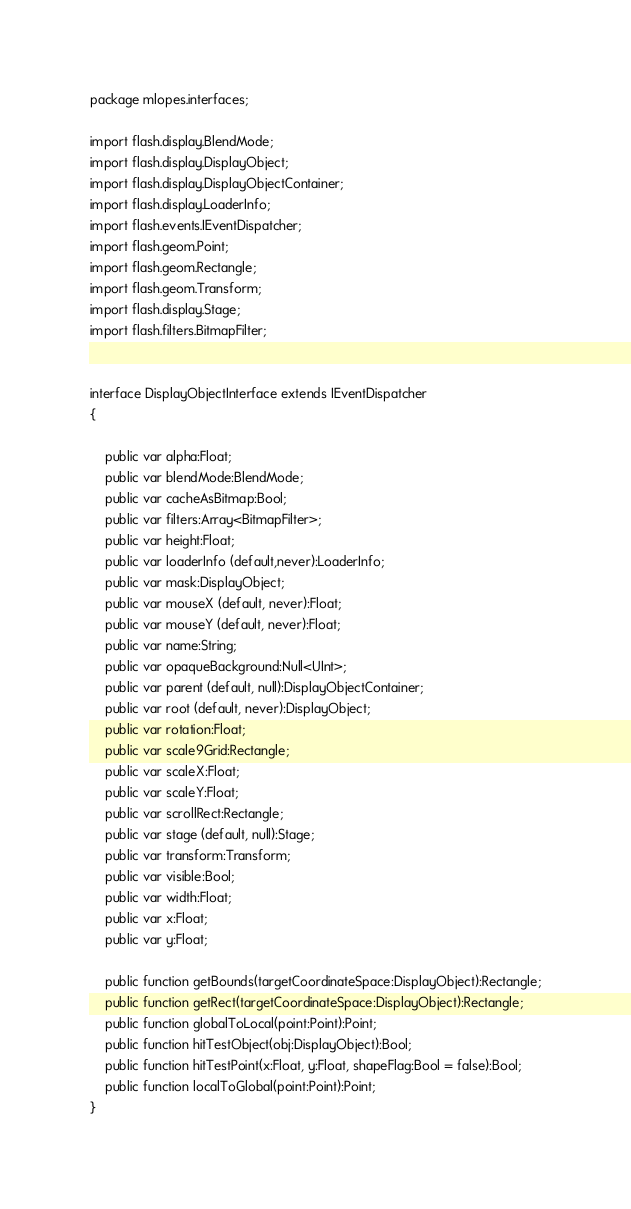<code> <loc_0><loc_0><loc_500><loc_500><_Haxe_>package mlopes.interfaces;

import flash.display.BlendMode;
import flash.display.DisplayObject;
import flash.display.DisplayObjectContainer;
import flash.display.LoaderInfo;
import flash.events.IEventDispatcher;
import flash.geom.Point;
import flash.geom.Rectangle;
import flash.geom.Transform;
import flash.display.Stage;
import flash.filters.BitmapFilter;


interface DisplayObjectInterface extends IEventDispatcher
{

    public var alpha:Float;
    public var blendMode:BlendMode;
    public var cacheAsBitmap:Bool;
    public var filters:Array<BitmapFilter>;
    public var height:Float;
    public var loaderInfo (default,never):LoaderInfo;
    public var mask:DisplayObject;
    public var mouseX (default, never):Float;
    public var mouseY (default, never):Float;
    public var name:String;
    public var opaqueBackground:Null<UInt>;
    public var parent (default, null):DisplayObjectContainer;
    public var root (default, never):DisplayObject;
    public var rotation:Float;
    public var scale9Grid:Rectangle;
    public var scaleX:Float;
    public var scaleY:Float;
    public var scrollRect:Rectangle;
    public var stage (default, null):Stage;
    public var transform:Transform;
    public var visible:Bool;
    public var width:Float;
    public var x:Float;
    public var y:Float;

    public function getBounds(targetCoordinateSpace:DisplayObject):Rectangle;
    public function getRect(targetCoordinateSpace:DisplayObject):Rectangle;
    public function globalToLocal(point:Point):Point;
    public function hitTestObject(obj:DisplayObject):Bool;
    public function hitTestPoint(x:Float, y:Float, shapeFlag:Bool = false):Bool;
    public function localToGlobal(point:Point):Point;
}</code> 